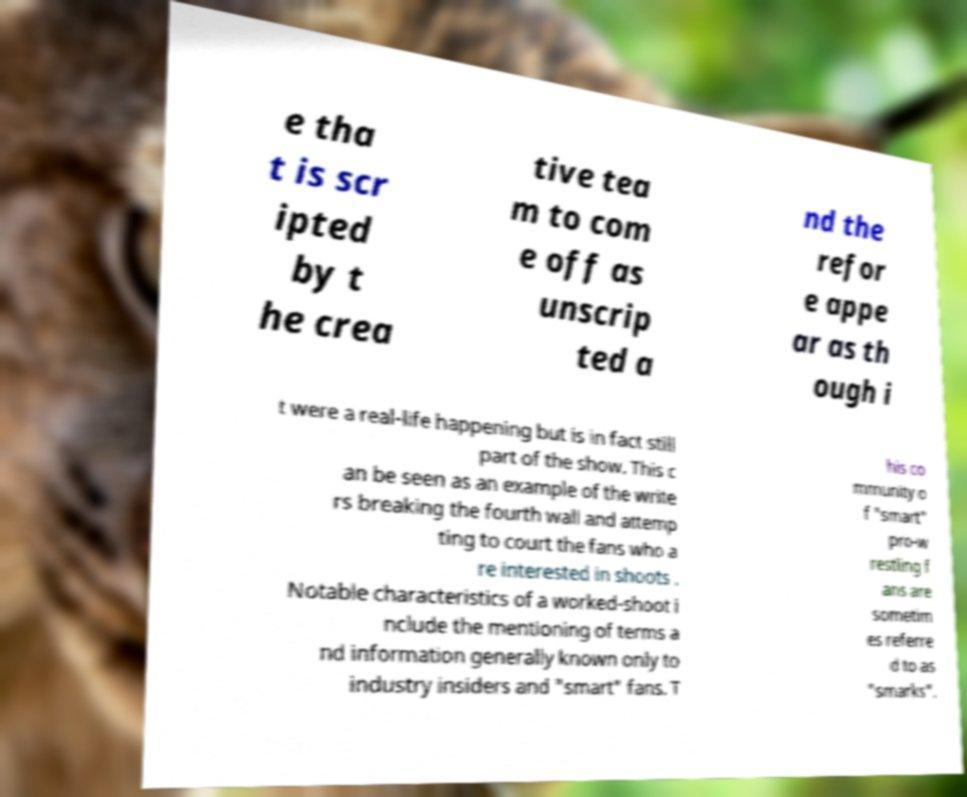Could you assist in decoding the text presented in this image and type it out clearly? e tha t is scr ipted by t he crea tive tea m to com e off as unscrip ted a nd the refor e appe ar as th ough i t were a real-life happening but is in fact still part of the show. This c an be seen as an example of the write rs breaking the fourth wall and attemp ting to court the fans who a re interested in shoots . Notable characteristics of a worked-shoot i nclude the mentioning of terms a nd information generally known only to industry insiders and "smart" fans. T his co mmunity o f "smart" pro-w restling f ans are sometim es referre d to as "smarks". 